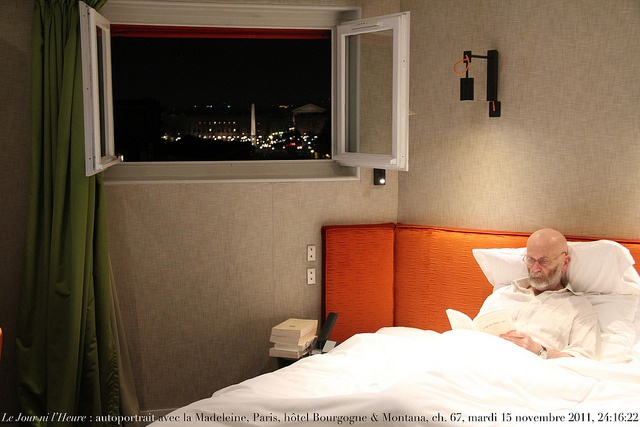Describe the objects in this image and their specific colors. I can see bed in black, ivory, tan, and darkgray tones, people in black, ivory, tan, and salmon tones, book in black, beige, tan, lightpink, and salmon tones, book in black, tan, and gray tones, and book in black, gray, and tan tones in this image. 